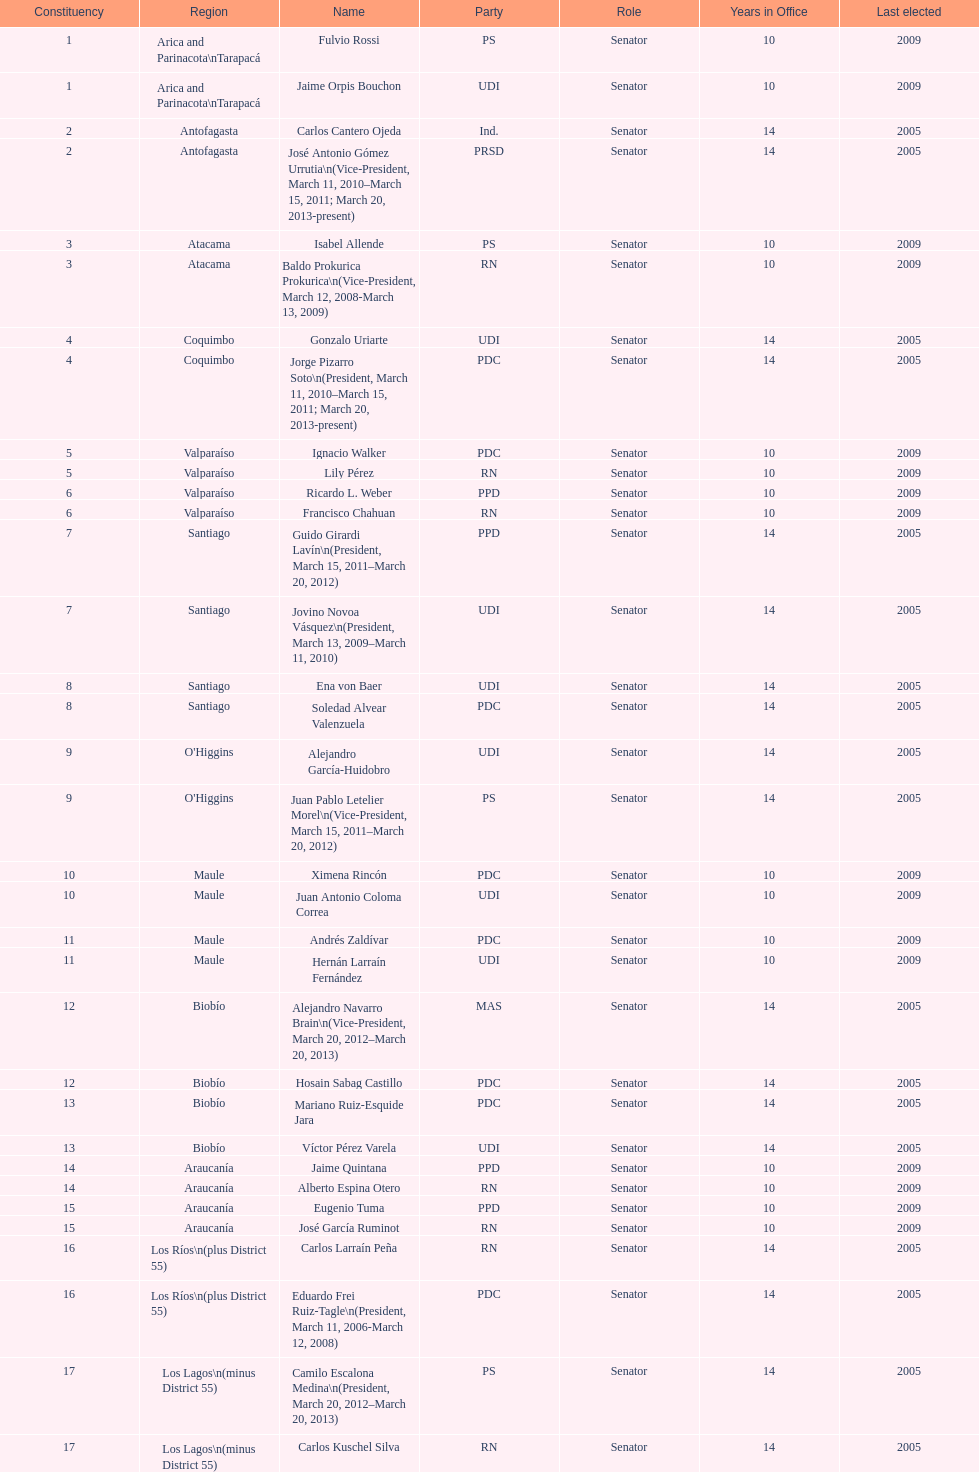Who was not last elected in either 2005 or 2009? Antonio Horvath Kiss. 